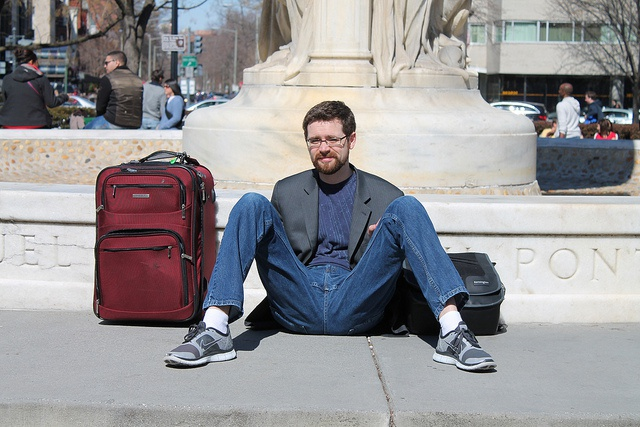Describe the objects in this image and their specific colors. I can see people in black, gray, and blue tones, suitcase in black, maroon, and brown tones, suitcase in black, gray, and darkblue tones, people in black, gray, and darkgray tones, and people in black, gray, and darkblue tones in this image. 